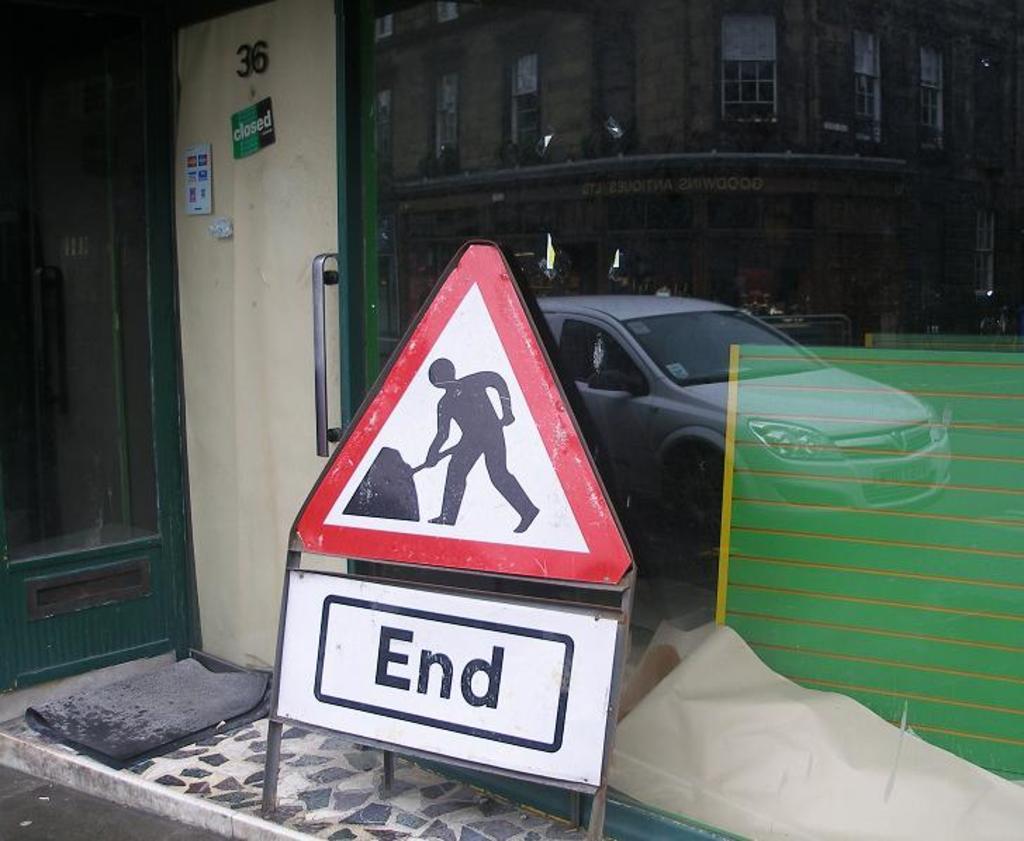What is the number hanging at the top of the door?
Ensure brevity in your answer.  36. What does the white sign say?
Make the answer very short. End. 